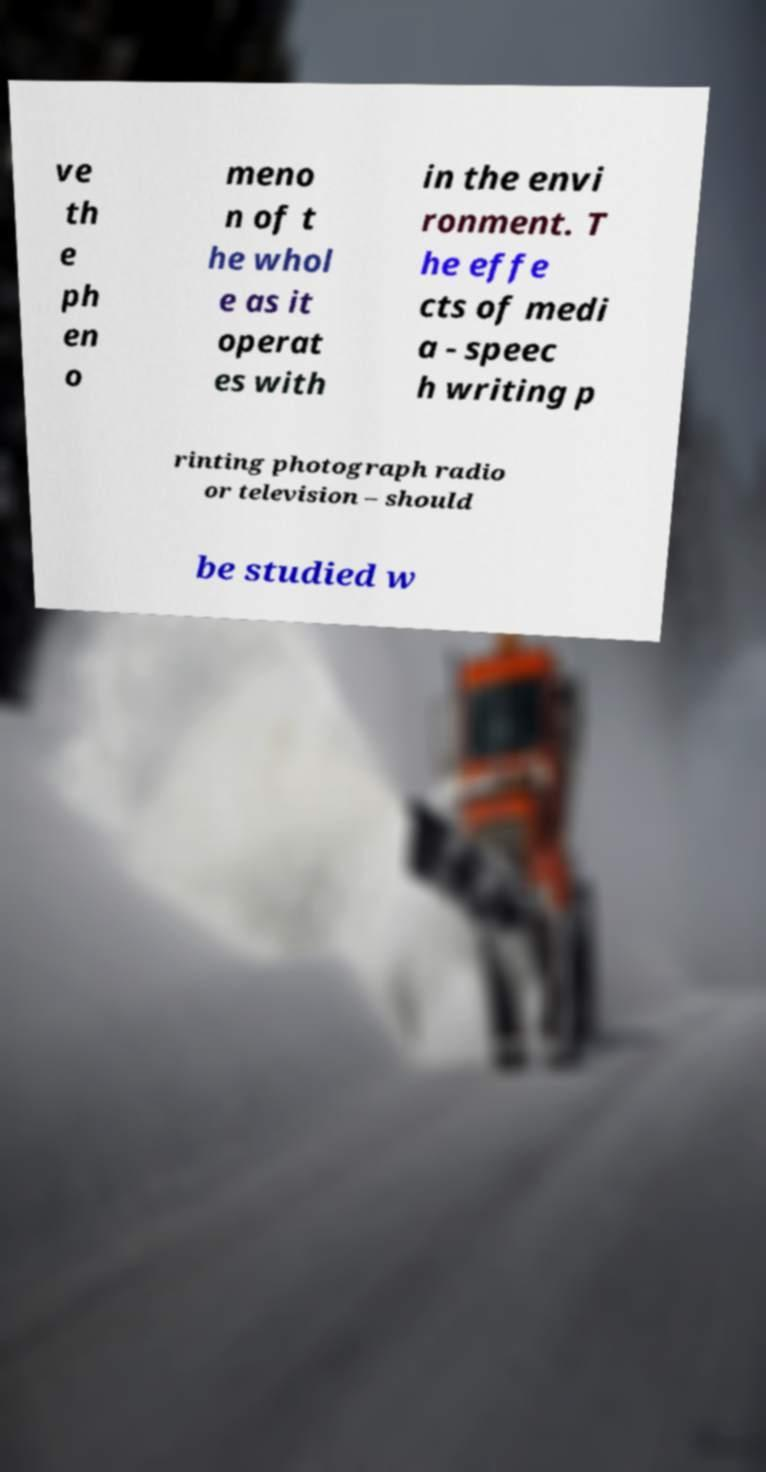Please identify and transcribe the text found in this image. ve th e ph en o meno n of t he whol e as it operat es with in the envi ronment. T he effe cts of medi a - speec h writing p rinting photograph radio or television – should be studied w 